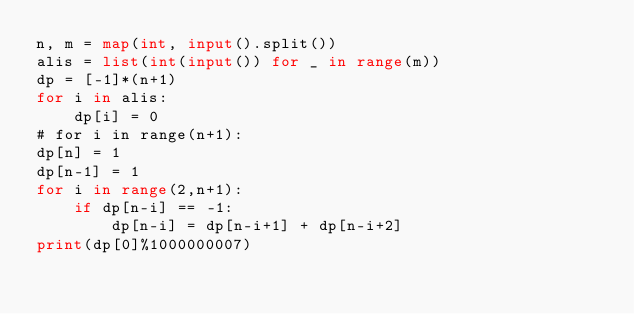<code> <loc_0><loc_0><loc_500><loc_500><_Python_>n, m = map(int, input().split())
alis = list(int(input()) for _ in range(m))
dp = [-1]*(n+1)
for i in alis:
    dp[i] = 0
# for i in range(n+1):
dp[n] = 1
dp[n-1] = 1
for i in range(2,n+1):
    if dp[n-i] == -1:
        dp[n-i] = dp[n-i+1] + dp[n-i+2]
print(dp[0]%1000000007)</code> 